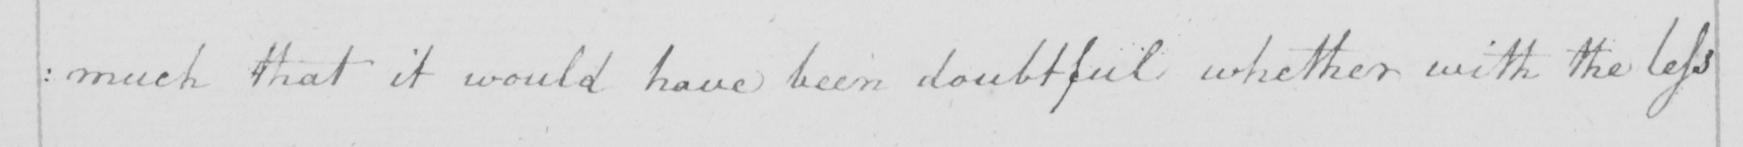Please transcribe the handwritten text in this image. :much that it would have been doubtful whether with the less 